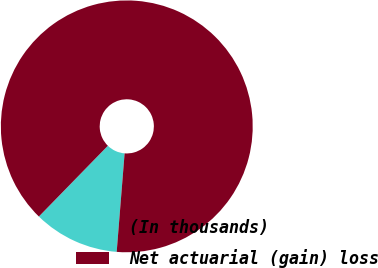Convert chart to OTSL. <chart><loc_0><loc_0><loc_500><loc_500><pie_chart><fcel>(In thousands)<fcel>Net actuarial (gain) loss<nl><fcel>11.02%<fcel>88.98%<nl></chart> 